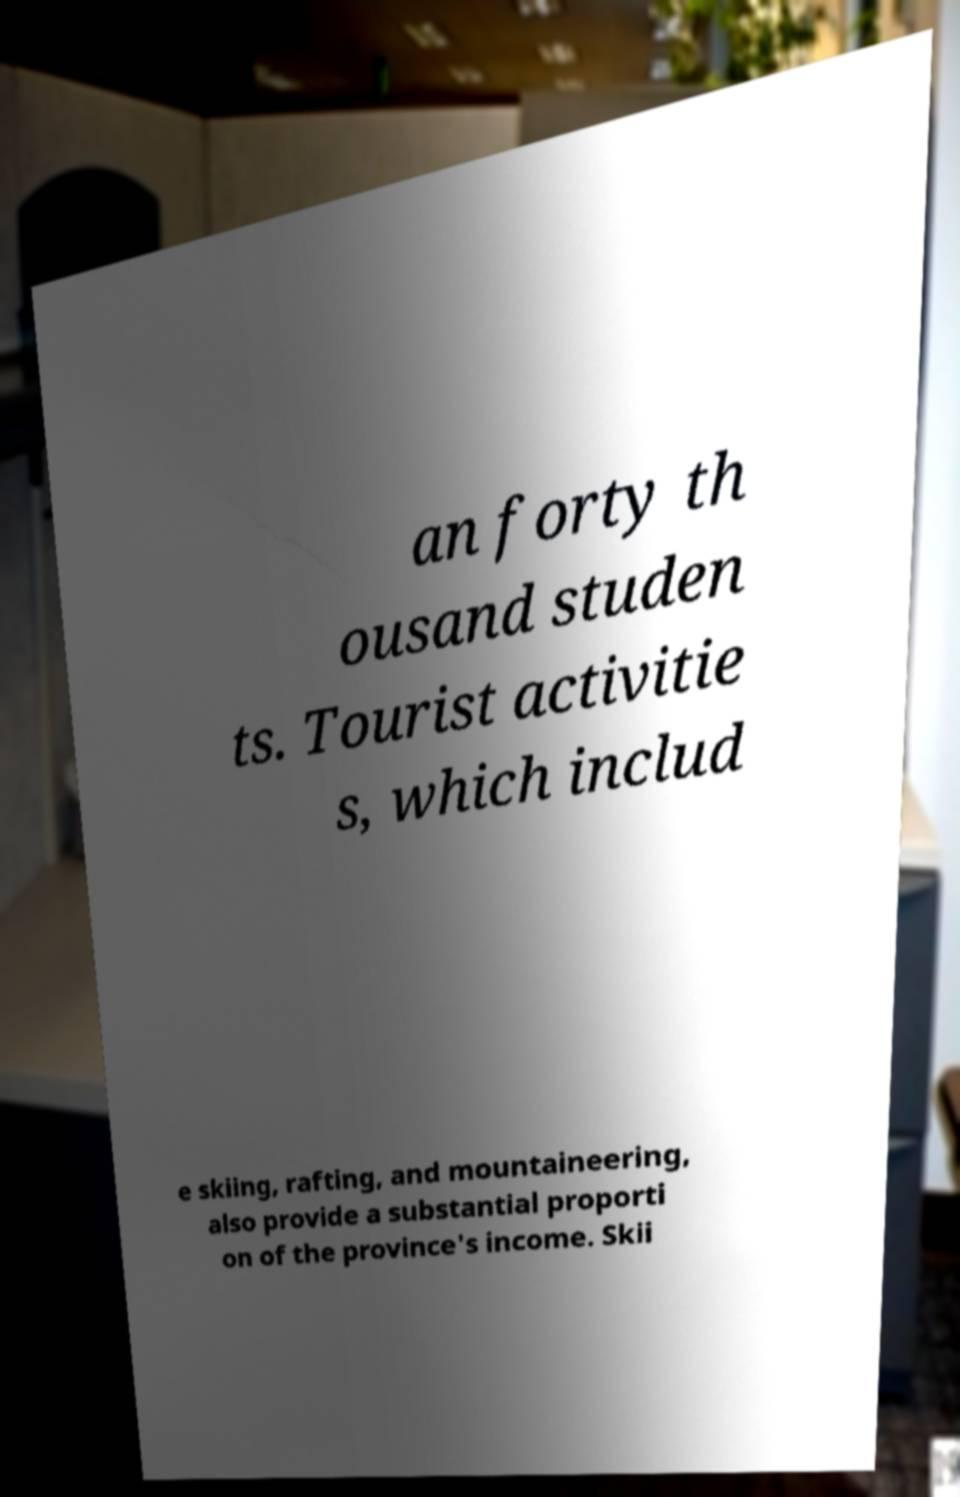Can you read and provide the text displayed in the image?This photo seems to have some interesting text. Can you extract and type it out for me? an forty th ousand studen ts. Tourist activitie s, which includ e skiing, rafting, and mountaineering, also provide a substantial proporti on of the province's income. Skii 